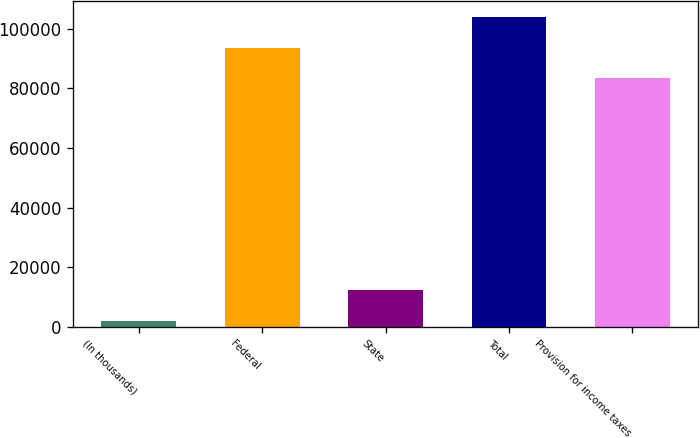Convert chart. <chart><loc_0><loc_0><loc_500><loc_500><bar_chart><fcel>(In thousands)<fcel>Federal<fcel>State<fcel>Total<fcel>Provision for income taxes<nl><fcel>2006<fcel>93572.3<fcel>12197.3<fcel>103919<fcel>83381<nl></chart> 